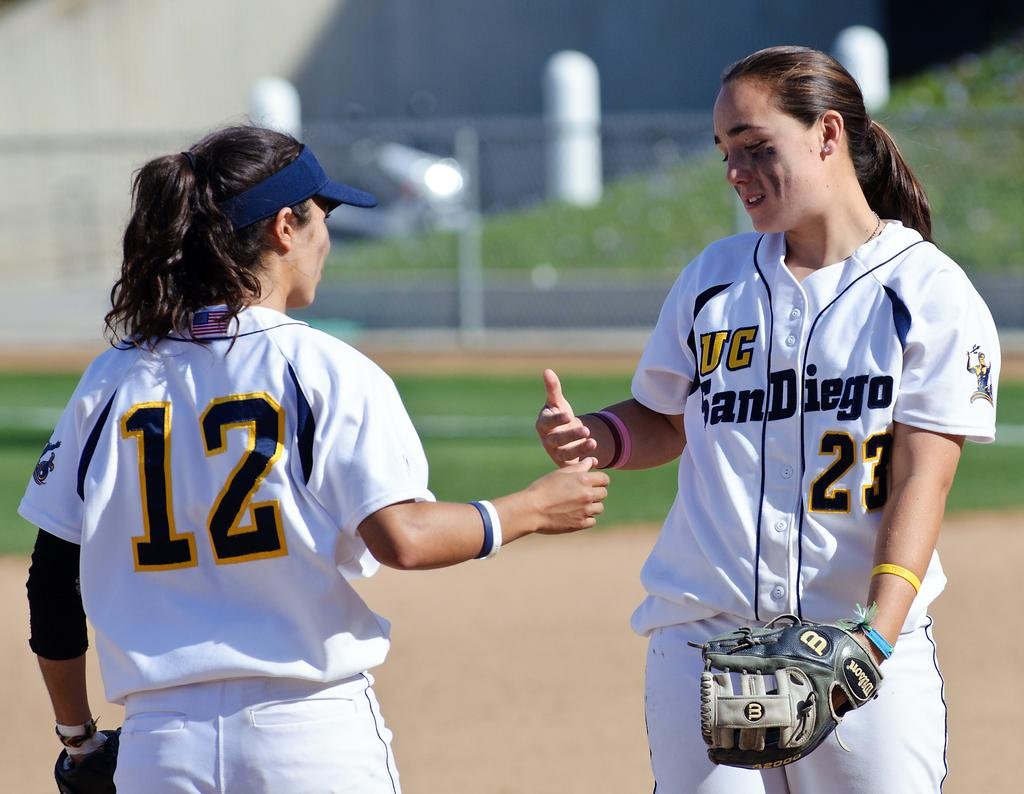<image>
Summarize the visual content of the image. Two women playing sports, one with the number 12 on her shirt. 